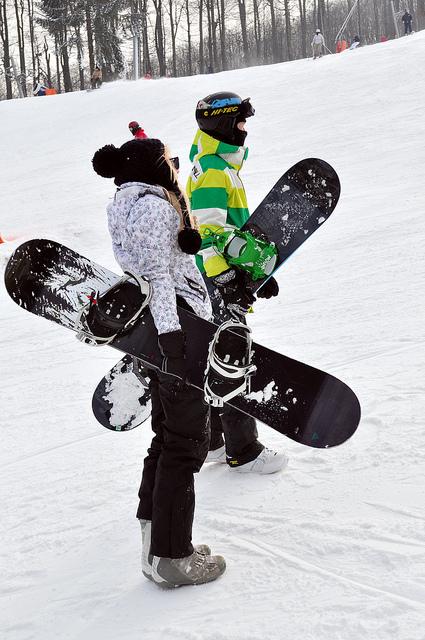How many snowboards are there?
Write a very short answer. 2. What is the gender of the person in the white jacket?
Give a very brief answer. Female. How many people are in this picture?
Answer briefly. 2. 